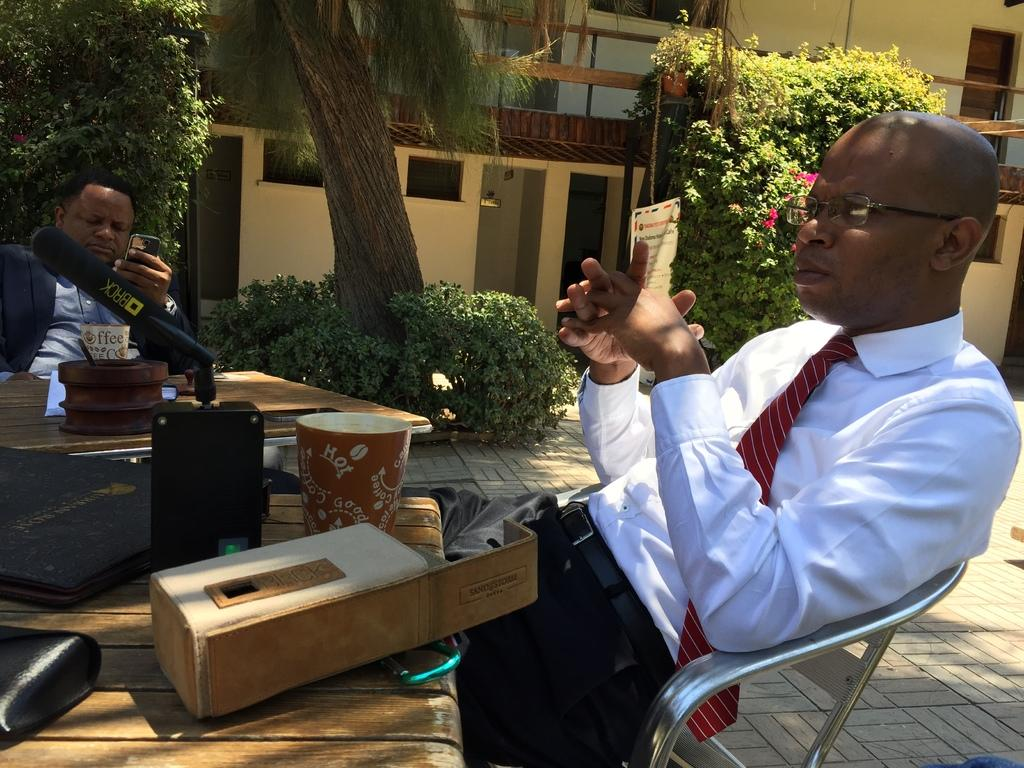Where is the person sitting in the image? There is a person sitting on a chair on the right side of the image. Can you describe the other person in the image? There is another person on the left side of the image. What can be seen in the background of the image? There are trees and a building in the background of the image. What type of seed is being used to paint the bead in the image? There is no seed or bead present in the image, and therefore no such activity can be observed. 